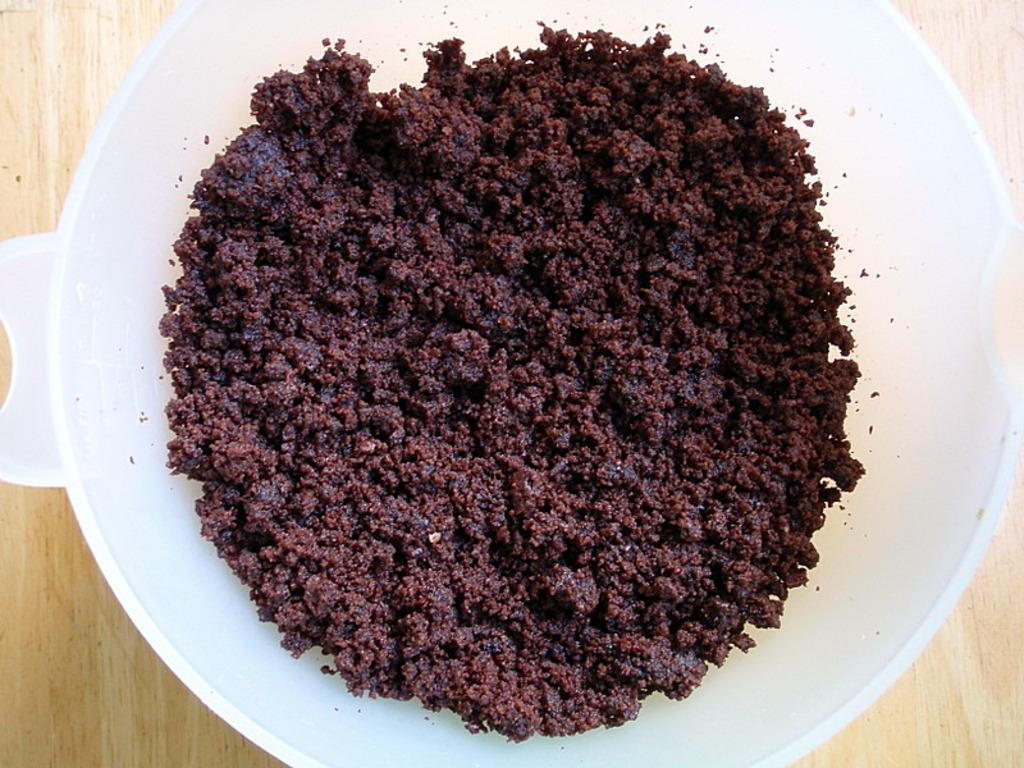What is the color of the surface in the image? The surface in the image is cream colored. What is placed on the surface? There is a white colored bowl on the surface. What is inside the bowl? The bowl contains brown and black colored food items. How many sheep are visible on the stage in the image? There are no sheep or stage present in the image. 